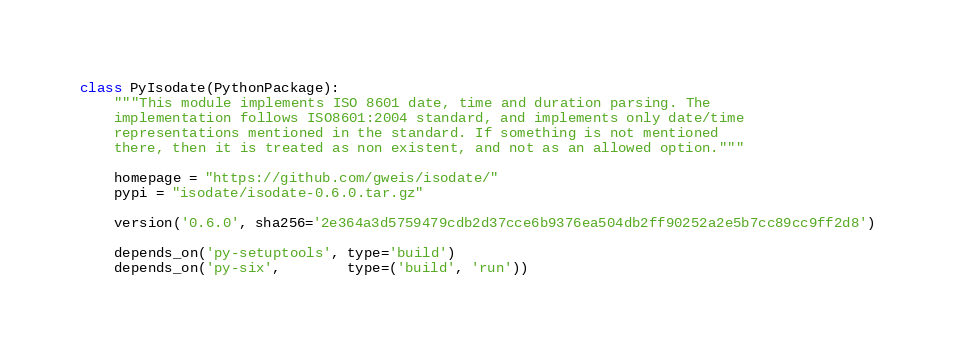Convert code to text. <code><loc_0><loc_0><loc_500><loc_500><_Python_>

class PyIsodate(PythonPackage):
    """This module implements ISO 8601 date, time and duration parsing. The
    implementation follows ISO8601:2004 standard, and implements only date/time
    representations mentioned in the standard. If something is not mentioned
    there, then it is treated as non existent, and not as an allowed option."""

    homepage = "https://github.com/gweis/isodate/"
    pypi = "isodate/isodate-0.6.0.tar.gz"

    version('0.6.0', sha256='2e364a3d5759479cdb2d37cce6b9376ea504db2ff90252a2e5b7cc89cc9ff2d8')

    depends_on('py-setuptools', type='build')
    depends_on('py-six',        type=('build', 'run'))
</code> 